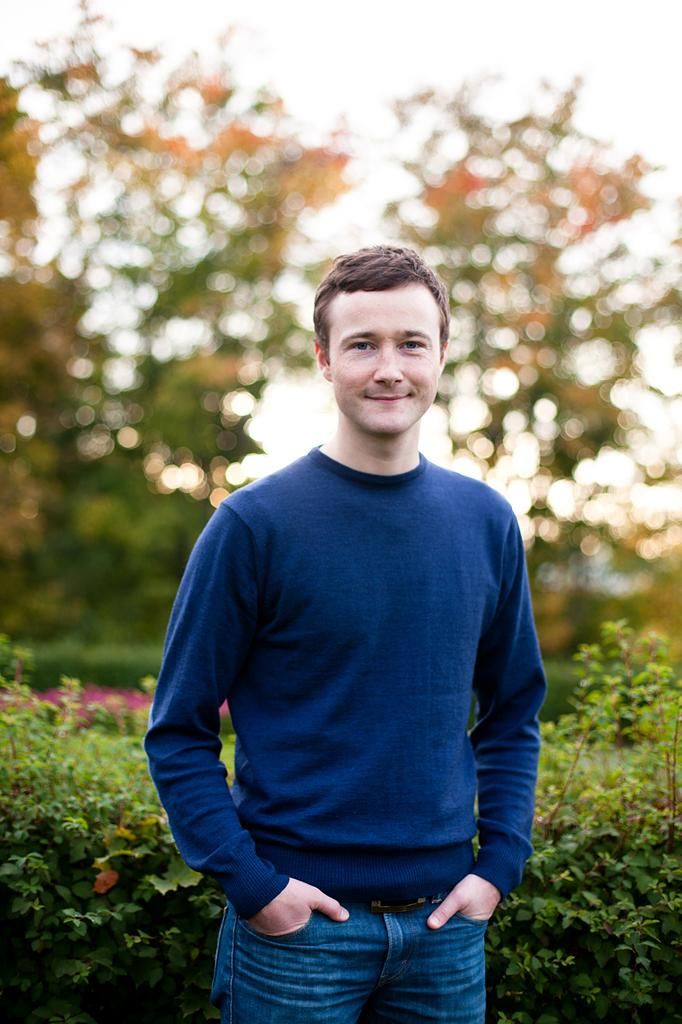What is the main subject of the image? There is a man standing in the center of the image. What is the man wearing in the image? The man is wearing a blue shirt. What can be seen in the background of the image? There are bushes and trees in the background of the image. What type of trousers is the man wearing in the image? The provided facts do not mention the type of trousers the man is wearing. Is the man cooking anything in the image? There is no indication in the image that the man is cooking or involved in any food preparation. 